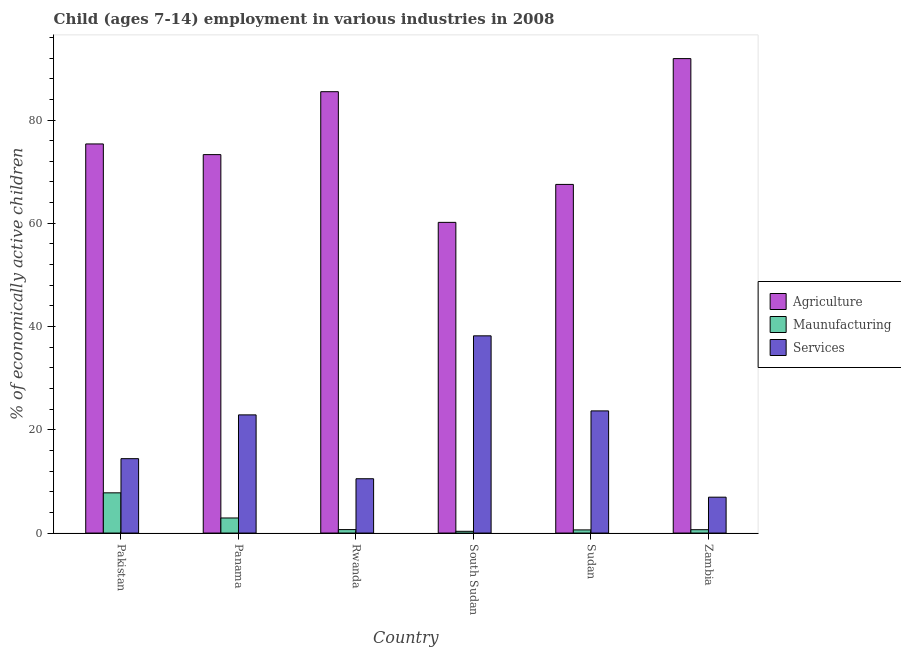Are the number of bars per tick equal to the number of legend labels?
Offer a terse response. Yes. Are the number of bars on each tick of the X-axis equal?
Your response must be concise. Yes. How many bars are there on the 5th tick from the left?
Offer a very short reply. 3. How many bars are there on the 6th tick from the right?
Provide a short and direct response. 3. What is the label of the 6th group of bars from the left?
Offer a terse response. Zambia. What is the percentage of economically active children in manufacturing in Sudan?
Your answer should be compact. 0.61. Across all countries, what is the maximum percentage of economically active children in agriculture?
Provide a short and direct response. 91.9. Across all countries, what is the minimum percentage of economically active children in services?
Your answer should be very brief. 6.95. In which country was the percentage of economically active children in services maximum?
Provide a succinct answer. South Sudan. In which country was the percentage of economically active children in agriculture minimum?
Your answer should be compact. South Sudan. What is the total percentage of economically active children in services in the graph?
Give a very brief answer. 116.63. What is the difference between the percentage of economically active children in agriculture in Sudan and that in Zambia?
Your answer should be compact. -24.37. What is the difference between the percentage of economically active children in manufacturing in Zambia and the percentage of economically active children in services in Rwanda?
Provide a succinct answer. -9.87. What is the average percentage of economically active children in agriculture per country?
Offer a terse response. 75.63. What is the difference between the percentage of economically active children in services and percentage of economically active children in agriculture in Zambia?
Keep it short and to the point. -84.95. In how many countries, is the percentage of economically active children in manufacturing greater than 8 %?
Your answer should be very brief. 0. What is the ratio of the percentage of economically active children in manufacturing in Panama to that in Rwanda?
Give a very brief answer. 4.36. What is the difference between the highest and the second highest percentage of economically active children in services?
Make the answer very short. 14.54. What is the difference between the highest and the lowest percentage of economically active children in manufacturing?
Offer a very short reply. 7.45. What does the 1st bar from the left in Panama represents?
Give a very brief answer. Agriculture. What does the 2nd bar from the right in Rwanda represents?
Offer a terse response. Maunufacturing. How many bars are there?
Keep it short and to the point. 18. Are all the bars in the graph horizontal?
Offer a terse response. No. What is the difference between two consecutive major ticks on the Y-axis?
Keep it short and to the point. 20. Does the graph contain any zero values?
Your answer should be very brief. No. How many legend labels are there?
Offer a terse response. 3. How are the legend labels stacked?
Make the answer very short. Vertical. What is the title of the graph?
Make the answer very short. Child (ages 7-14) employment in various industries in 2008. Does "Ores and metals" appear as one of the legend labels in the graph?
Make the answer very short. No. What is the label or title of the Y-axis?
Keep it short and to the point. % of economically active children. What is the % of economically active children in Agriculture in Pakistan?
Ensure brevity in your answer.  75.37. What is the % of economically active children of Maunufacturing in Pakistan?
Ensure brevity in your answer.  7.79. What is the % of economically active children of Services in Pakistan?
Your response must be concise. 14.41. What is the % of economically active children of Agriculture in Panama?
Give a very brief answer. 73.3. What is the % of economically active children in Maunufacturing in Panama?
Keep it short and to the point. 2.92. What is the % of economically active children in Services in Panama?
Offer a very short reply. 22.89. What is the % of economically active children of Agriculture in Rwanda?
Ensure brevity in your answer.  85.49. What is the % of economically active children in Maunufacturing in Rwanda?
Keep it short and to the point. 0.67. What is the % of economically active children of Services in Rwanda?
Keep it short and to the point. 10.52. What is the % of economically active children of Agriculture in South Sudan?
Offer a terse response. 60.18. What is the % of economically active children in Maunufacturing in South Sudan?
Provide a short and direct response. 0.34. What is the % of economically active children of Services in South Sudan?
Offer a very short reply. 38.2. What is the % of economically active children of Agriculture in Sudan?
Give a very brief answer. 67.53. What is the % of economically active children in Maunufacturing in Sudan?
Your answer should be compact. 0.61. What is the % of economically active children of Services in Sudan?
Provide a short and direct response. 23.66. What is the % of economically active children of Agriculture in Zambia?
Your answer should be compact. 91.9. What is the % of economically active children of Maunufacturing in Zambia?
Your answer should be compact. 0.65. What is the % of economically active children in Services in Zambia?
Ensure brevity in your answer.  6.95. Across all countries, what is the maximum % of economically active children of Agriculture?
Provide a succinct answer. 91.9. Across all countries, what is the maximum % of economically active children in Maunufacturing?
Offer a terse response. 7.79. Across all countries, what is the maximum % of economically active children of Services?
Offer a very short reply. 38.2. Across all countries, what is the minimum % of economically active children in Agriculture?
Make the answer very short. 60.18. Across all countries, what is the minimum % of economically active children in Maunufacturing?
Give a very brief answer. 0.34. Across all countries, what is the minimum % of economically active children of Services?
Make the answer very short. 6.95. What is the total % of economically active children of Agriculture in the graph?
Ensure brevity in your answer.  453.77. What is the total % of economically active children of Maunufacturing in the graph?
Keep it short and to the point. 12.98. What is the total % of economically active children of Services in the graph?
Your response must be concise. 116.63. What is the difference between the % of economically active children of Agriculture in Pakistan and that in Panama?
Provide a short and direct response. 2.07. What is the difference between the % of economically active children in Maunufacturing in Pakistan and that in Panama?
Give a very brief answer. 4.87. What is the difference between the % of economically active children of Services in Pakistan and that in Panama?
Make the answer very short. -8.48. What is the difference between the % of economically active children in Agriculture in Pakistan and that in Rwanda?
Provide a short and direct response. -10.12. What is the difference between the % of economically active children in Maunufacturing in Pakistan and that in Rwanda?
Offer a terse response. 7.12. What is the difference between the % of economically active children in Services in Pakistan and that in Rwanda?
Your answer should be compact. 3.89. What is the difference between the % of economically active children in Agriculture in Pakistan and that in South Sudan?
Your answer should be very brief. 15.19. What is the difference between the % of economically active children of Maunufacturing in Pakistan and that in South Sudan?
Your answer should be compact. 7.45. What is the difference between the % of economically active children in Services in Pakistan and that in South Sudan?
Give a very brief answer. -23.79. What is the difference between the % of economically active children of Agriculture in Pakistan and that in Sudan?
Keep it short and to the point. 7.84. What is the difference between the % of economically active children in Maunufacturing in Pakistan and that in Sudan?
Give a very brief answer. 7.18. What is the difference between the % of economically active children in Services in Pakistan and that in Sudan?
Offer a very short reply. -9.25. What is the difference between the % of economically active children in Agriculture in Pakistan and that in Zambia?
Ensure brevity in your answer.  -16.53. What is the difference between the % of economically active children of Maunufacturing in Pakistan and that in Zambia?
Make the answer very short. 7.14. What is the difference between the % of economically active children in Services in Pakistan and that in Zambia?
Make the answer very short. 7.46. What is the difference between the % of economically active children of Agriculture in Panama and that in Rwanda?
Ensure brevity in your answer.  -12.19. What is the difference between the % of economically active children in Maunufacturing in Panama and that in Rwanda?
Your answer should be compact. 2.25. What is the difference between the % of economically active children in Services in Panama and that in Rwanda?
Your response must be concise. 12.37. What is the difference between the % of economically active children in Agriculture in Panama and that in South Sudan?
Offer a very short reply. 13.12. What is the difference between the % of economically active children of Maunufacturing in Panama and that in South Sudan?
Provide a succinct answer. 2.58. What is the difference between the % of economically active children of Services in Panama and that in South Sudan?
Provide a succinct answer. -15.31. What is the difference between the % of economically active children in Agriculture in Panama and that in Sudan?
Provide a succinct answer. 5.77. What is the difference between the % of economically active children in Maunufacturing in Panama and that in Sudan?
Offer a terse response. 2.31. What is the difference between the % of economically active children of Services in Panama and that in Sudan?
Offer a terse response. -0.77. What is the difference between the % of economically active children of Agriculture in Panama and that in Zambia?
Your answer should be compact. -18.6. What is the difference between the % of economically active children of Maunufacturing in Panama and that in Zambia?
Keep it short and to the point. 2.27. What is the difference between the % of economically active children of Services in Panama and that in Zambia?
Your answer should be very brief. 15.94. What is the difference between the % of economically active children in Agriculture in Rwanda and that in South Sudan?
Provide a succinct answer. 25.31. What is the difference between the % of economically active children in Maunufacturing in Rwanda and that in South Sudan?
Make the answer very short. 0.33. What is the difference between the % of economically active children in Services in Rwanda and that in South Sudan?
Make the answer very short. -27.68. What is the difference between the % of economically active children of Agriculture in Rwanda and that in Sudan?
Offer a very short reply. 17.96. What is the difference between the % of economically active children in Services in Rwanda and that in Sudan?
Offer a terse response. -13.14. What is the difference between the % of economically active children of Agriculture in Rwanda and that in Zambia?
Offer a very short reply. -6.41. What is the difference between the % of economically active children in Services in Rwanda and that in Zambia?
Offer a terse response. 3.57. What is the difference between the % of economically active children in Agriculture in South Sudan and that in Sudan?
Ensure brevity in your answer.  -7.35. What is the difference between the % of economically active children of Maunufacturing in South Sudan and that in Sudan?
Keep it short and to the point. -0.27. What is the difference between the % of economically active children of Services in South Sudan and that in Sudan?
Offer a very short reply. 14.54. What is the difference between the % of economically active children of Agriculture in South Sudan and that in Zambia?
Ensure brevity in your answer.  -31.72. What is the difference between the % of economically active children of Maunufacturing in South Sudan and that in Zambia?
Give a very brief answer. -0.31. What is the difference between the % of economically active children in Services in South Sudan and that in Zambia?
Keep it short and to the point. 31.25. What is the difference between the % of economically active children in Agriculture in Sudan and that in Zambia?
Your answer should be compact. -24.37. What is the difference between the % of economically active children in Maunufacturing in Sudan and that in Zambia?
Your response must be concise. -0.04. What is the difference between the % of economically active children in Services in Sudan and that in Zambia?
Keep it short and to the point. 16.71. What is the difference between the % of economically active children of Agriculture in Pakistan and the % of economically active children of Maunufacturing in Panama?
Your answer should be very brief. 72.45. What is the difference between the % of economically active children in Agriculture in Pakistan and the % of economically active children in Services in Panama?
Keep it short and to the point. 52.48. What is the difference between the % of economically active children in Maunufacturing in Pakistan and the % of economically active children in Services in Panama?
Your answer should be compact. -15.1. What is the difference between the % of economically active children in Agriculture in Pakistan and the % of economically active children in Maunufacturing in Rwanda?
Your response must be concise. 74.7. What is the difference between the % of economically active children in Agriculture in Pakistan and the % of economically active children in Services in Rwanda?
Your answer should be very brief. 64.85. What is the difference between the % of economically active children in Maunufacturing in Pakistan and the % of economically active children in Services in Rwanda?
Your answer should be very brief. -2.73. What is the difference between the % of economically active children of Agriculture in Pakistan and the % of economically active children of Maunufacturing in South Sudan?
Ensure brevity in your answer.  75.03. What is the difference between the % of economically active children in Agriculture in Pakistan and the % of economically active children in Services in South Sudan?
Offer a very short reply. 37.17. What is the difference between the % of economically active children in Maunufacturing in Pakistan and the % of economically active children in Services in South Sudan?
Offer a very short reply. -30.41. What is the difference between the % of economically active children in Agriculture in Pakistan and the % of economically active children in Maunufacturing in Sudan?
Your answer should be compact. 74.76. What is the difference between the % of economically active children of Agriculture in Pakistan and the % of economically active children of Services in Sudan?
Keep it short and to the point. 51.71. What is the difference between the % of economically active children in Maunufacturing in Pakistan and the % of economically active children in Services in Sudan?
Ensure brevity in your answer.  -15.87. What is the difference between the % of economically active children in Agriculture in Pakistan and the % of economically active children in Maunufacturing in Zambia?
Your answer should be compact. 74.72. What is the difference between the % of economically active children of Agriculture in Pakistan and the % of economically active children of Services in Zambia?
Offer a very short reply. 68.42. What is the difference between the % of economically active children in Maunufacturing in Pakistan and the % of economically active children in Services in Zambia?
Offer a very short reply. 0.84. What is the difference between the % of economically active children in Agriculture in Panama and the % of economically active children in Maunufacturing in Rwanda?
Keep it short and to the point. 72.63. What is the difference between the % of economically active children in Agriculture in Panama and the % of economically active children in Services in Rwanda?
Your answer should be compact. 62.78. What is the difference between the % of economically active children in Agriculture in Panama and the % of economically active children in Maunufacturing in South Sudan?
Keep it short and to the point. 72.96. What is the difference between the % of economically active children in Agriculture in Panama and the % of economically active children in Services in South Sudan?
Make the answer very short. 35.1. What is the difference between the % of economically active children of Maunufacturing in Panama and the % of economically active children of Services in South Sudan?
Keep it short and to the point. -35.28. What is the difference between the % of economically active children in Agriculture in Panama and the % of economically active children in Maunufacturing in Sudan?
Offer a very short reply. 72.69. What is the difference between the % of economically active children of Agriculture in Panama and the % of economically active children of Services in Sudan?
Your answer should be very brief. 49.64. What is the difference between the % of economically active children of Maunufacturing in Panama and the % of economically active children of Services in Sudan?
Your answer should be compact. -20.74. What is the difference between the % of economically active children of Agriculture in Panama and the % of economically active children of Maunufacturing in Zambia?
Your answer should be very brief. 72.65. What is the difference between the % of economically active children in Agriculture in Panama and the % of economically active children in Services in Zambia?
Provide a short and direct response. 66.35. What is the difference between the % of economically active children of Maunufacturing in Panama and the % of economically active children of Services in Zambia?
Offer a terse response. -4.03. What is the difference between the % of economically active children of Agriculture in Rwanda and the % of economically active children of Maunufacturing in South Sudan?
Keep it short and to the point. 85.15. What is the difference between the % of economically active children in Agriculture in Rwanda and the % of economically active children in Services in South Sudan?
Offer a very short reply. 47.29. What is the difference between the % of economically active children in Maunufacturing in Rwanda and the % of economically active children in Services in South Sudan?
Provide a succinct answer. -37.53. What is the difference between the % of economically active children of Agriculture in Rwanda and the % of economically active children of Maunufacturing in Sudan?
Give a very brief answer. 84.88. What is the difference between the % of economically active children of Agriculture in Rwanda and the % of economically active children of Services in Sudan?
Make the answer very short. 61.83. What is the difference between the % of economically active children of Maunufacturing in Rwanda and the % of economically active children of Services in Sudan?
Your response must be concise. -22.99. What is the difference between the % of economically active children in Agriculture in Rwanda and the % of economically active children in Maunufacturing in Zambia?
Offer a very short reply. 84.84. What is the difference between the % of economically active children in Agriculture in Rwanda and the % of economically active children in Services in Zambia?
Provide a succinct answer. 78.54. What is the difference between the % of economically active children in Maunufacturing in Rwanda and the % of economically active children in Services in Zambia?
Give a very brief answer. -6.28. What is the difference between the % of economically active children of Agriculture in South Sudan and the % of economically active children of Maunufacturing in Sudan?
Offer a terse response. 59.57. What is the difference between the % of economically active children of Agriculture in South Sudan and the % of economically active children of Services in Sudan?
Keep it short and to the point. 36.52. What is the difference between the % of economically active children of Maunufacturing in South Sudan and the % of economically active children of Services in Sudan?
Your answer should be compact. -23.32. What is the difference between the % of economically active children of Agriculture in South Sudan and the % of economically active children of Maunufacturing in Zambia?
Your answer should be compact. 59.53. What is the difference between the % of economically active children of Agriculture in South Sudan and the % of economically active children of Services in Zambia?
Your response must be concise. 53.23. What is the difference between the % of economically active children in Maunufacturing in South Sudan and the % of economically active children in Services in Zambia?
Provide a succinct answer. -6.61. What is the difference between the % of economically active children of Agriculture in Sudan and the % of economically active children of Maunufacturing in Zambia?
Offer a terse response. 66.88. What is the difference between the % of economically active children of Agriculture in Sudan and the % of economically active children of Services in Zambia?
Provide a succinct answer. 60.58. What is the difference between the % of economically active children in Maunufacturing in Sudan and the % of economically active children in Services in Zambia?
Provide a short and direct response. -6.34. What is the average % of economically active children in Agriculture per country?
Give a very brief answer. 75.63. What is the average % of economically active children in Maunufacturing per country?
Your answer should be compact. 2.16. What is the average % of economically active children of Services per country?
Provide a succinct answer. 19.44. What is the difference between the % of economically active children of Agriculture and % of economically active children of Maunufacturing in Pakistan?
Your response must be concise. 67.58. What is the difference between the % of economically active children of Agriculture and % of economically active children of Services in Pakistan?
Your answer should be compact. 60.96. What is the difference between the % of economically active children in Maunufacturing and % of economically active children in Services in Pakistan?
Your response must be concise. -6.62. What is the difference between the % of economically active children of Agriculture and % of economically active children of Maunufacturing in Panama?
Ensure brevity in your answer.  70.38. What is the difference between the % of economically active children of Agriculture and % of economically active children of Services in Panama?
Provide a short and direct response. 50.41. What is the difference between the % of economically active children of Maunufacturing and % of economically active children of Services in Panama?
Ensure brevity in your answer.  -19.97. What is the difference between the % of economically active children in Agriculture and % of economically active children in Maunufacturing in Rwanda?
Your response must be concise. 84.82. What is the difference between the % of economically active children of Agriculture and % of economically active children of Services in Rwanda?
Give a very brief answer. 74.97. What is the difference between the % of economically active children in Maunufacturing and % of economically active children in Services in Rwanda?
Offer a terse response. -9.85. What is the difference between the % of economically active children in Agriculture and % of economically active children in Maunufacturing in South Sudan?
Your response must be concise. 59.84. What is the difference between the % of economically active children of Agriculture and % of economically active children of Services in South Sudan?
Keep it short and to the point. 21.98. What is the difference between the % of economically active children of Maunufacturing and % of economically active children of Services in South Sudan?
Give a very brief answer. -37.86. What is the difference between the % of economically active children in Agriculture and % of economically active children in Maunufacturing in Sudan?
Your answer should be compact. 66.92. What is the difference between the % of economically active children in Agriculture and % of economically active children in Services in Sudan?
Provide a short and direct response. 43.87. What is the difference between the % of economically active children in Maunufacturing and % of economically active children in Services in Sudan?
Provide a short and direct response. -23.05. What is the difference between the % of economically active children of Agriculture and % of economically active children of Maunufacturing in Zambia?
Your answer should be compact. 91.25. What is the difference between the % of economically active children in Agriculture and % of economically active children in Services in Zambia?
Make the answer very short. 84.95. What is the ratio of the % of economically active children of Agriculture in Pakistan to that in Panama?
Your answer should be very brief. 1.03. What is the ratio of the % of economically active children in Maunufacturing in Pakistan to that in Panama?
Your response must be concise. 2.67. What is the ratio of the % of economically active children in Services in Pakistan to that in Panama?
Provide a succinct answer. 0.63. What is the ratio of the % of economically active children in Agriculture in Pakistan to that in Rwanda?
Provide a short and direct response. 0.88. What is the ratio of the % of economically active children of Maunufacturing in Pakistan to that in Rwanda?
Your response must be concise. 11.63. What is the ratio of the % of economically active children of Services in Pakistan to that in Rwanda?
Keep it short and to the point. 1.37. What is the ratio of the % of economically active children of Agriculture in Pakistan to that in South Sudan?
Offer a terse response. 1.25. What is the ratio of the % of economically active children in Maunufacturing in Pakistan to that in South Sudan?
Your answer should be compact. 22.91. What is the ratio of the % of economically active children of Services in Pakistan to that in South Sudan?
Your answer should be very brief. 0.38. What is the ratio of the % of economically active children in Agriculture in Pakistan to that in Sudan?
Provide a short and direct response. 1.12. What is the ratio of the % of economically active children of Maunufacturing in Pakistan to that in Sudan?
Provide a succinct answer. 12.77. What is the ratio of the % of economically active children of Services in Pakistan to that in Sudan?
Ensure brevity in your answer.  0.61. What is the ratio of the % of economically active children in Agriculture in Pakistan to that in Zambia?
Offer a terse response. 0.82. What is the ratio of the % of economically active children in Maunufacturing in Pakistan to that in Zambia?
Ensure brevity in your answer.  11.98. What is the ratio of the % of economically active children of Services in Pakistan to that in Zambia?
Ensure brevity in your answer.  2.07. What is the ratio of the % of economically active children in Agriculture in Panama to that in Rwanda?
Provide a succinct answer. 0.86. What is the ratio of the % of economically active children in Maunufacturing in Panama to that in Rwanda?
Give a very brief answer. 4.36. What is the ratio of the % of economically active children in Services in Panama to that in Rwanda?
Offer a very short reply. 2.18. What is the ratio of the % of economically active children of Agriculture in Panama to that in South Sudan?
Provide a succinct answer. 1.22. What is the ratio of the % of economically active children of Maunufacturing in Panama to that in South Sudan?
Your answer should be very brief. 8.59. What is the ratio of the % of economically active children in Services in Panama to that in South Sudan?
Your answer should be compact. 0.6. What is the ratio of the % of economically active children in Agriculture in Panama to that in Sudan?
Offer a terse response. 1.09. What is the ratio of the % of economically active children of Maunufacturing in Panama to that in Sudan?
Ensure brevity in your answer.  4.79. What is the ratio of the % of economically active children in Services in Panama to that in Sudan?
Ensure brevity in your answer.  0.97. What is the ratio of the % of economically active children of Agriculture in Panama to that in Zambia?
Make the answer very short. 0.8. What is the ratio of the % of economically active children of Maunufacturing in Panama to that in Zambia?
Provide a succinct answer. 4.49. What is the ratio of the % of economically active children of Services in Panama to that in Zambia?
Make the answer very short. 3.29. What is the ratio of the % of economically active children in Agriculture in Rwanda to that in South Sudan?
Offer a terse response. 1.42. What is the ratio of the % of economically active children in Maunufacturing in Rwanda to that in South Sudan?
Your answer should be compact. 1.97. What is the ratio of the % of economically active children in Services in Rwanda to that in South Sudan?
Provide a succinct answer. 0.28. What is the ratio of the % of economically active children of Agriculture in Rwanda to that in Sudan?
Provide a succinct answer. 1.27. What is the ratio of the % of economically active children in Maunufacturing in Rwanda to that in Sudan?
Make the answer very short. 1.1. What is the ratio of the % of economically active children of Services in Rwanda to that in Sudan?
Keep it short and to the point. 0.44. What is the ratio of the % of economically active children of Agriculture in Rwanda to that in Zambia?
Provide a succinct answer. 0.93. What is the ratio of the % of economically active children in Maunufacturing in Rwanda to that in Zambia?
Provide a short and direct response. 1.03. What is the ratio of the % of economically active children of Services in Rwanda to that in Zambia?
Offer a terse response. 1.51. What is the ratio of the % of economically active children in Agriculture in South Sudan to that in Sudan?
Offer a very short reply. 0.89. What is the ratio of the % of economically active children of Maunufacturing in South Sudan to that in Sudan?
Make the answer very short. 0.56. What is the ratio of the % of economically active children of Services in South Sudan to that in Sudan?
Provide a succinct answer. 1.61. What is the ratio of the % of economically active children of Agriculture in South Sudan to that in Zambia?
Provide a succinct answer. 0.65. What is the ratio of the % of economically active children of Maunufacturing in South Sudan to that in Zambia?
Offer a terse response. 0.52. What is the ratio of the % of economically active children of Services in South Sudan to that in Zambia?
Provide a short and direct response. 5.5. What is the ratio of the % of economically active children of Agriculture in Sudan to that in Zambia?
Provide a succinct answer. 0.73. What is the ratio of the % of economically active children of Maunufacturing in Sudan to that in Zambia?
Your response must be concise. 0.94. What is the ratio of the % of economically active children of Services in Sudan to that in Zambia?
Your response must be concise. 3.4. What is the difference between the highest and the second highest % of economically active children of Agriculture?
Your answer should be compact. 6.41. What is the difference between the highest and the second highest % of economically active children of Maunufacturing?
Offer a very short reply. 4.87. What is the difference between the highest and the second highest % of economically active children in Services?
Provide a succinct answer. 14.54. What is the difference between the highest and the lowest % of economically active children in Agriculture?
Ensure brevity in your answer.  31.72. What is the difference between the highest and the lowest % of economically active children of Maunufacturing?
Provide a succinct answer. 7.45. What is the difference between the highest and the lowest % of economically active children of Services?
Provide a succinct answer. 31.25. 